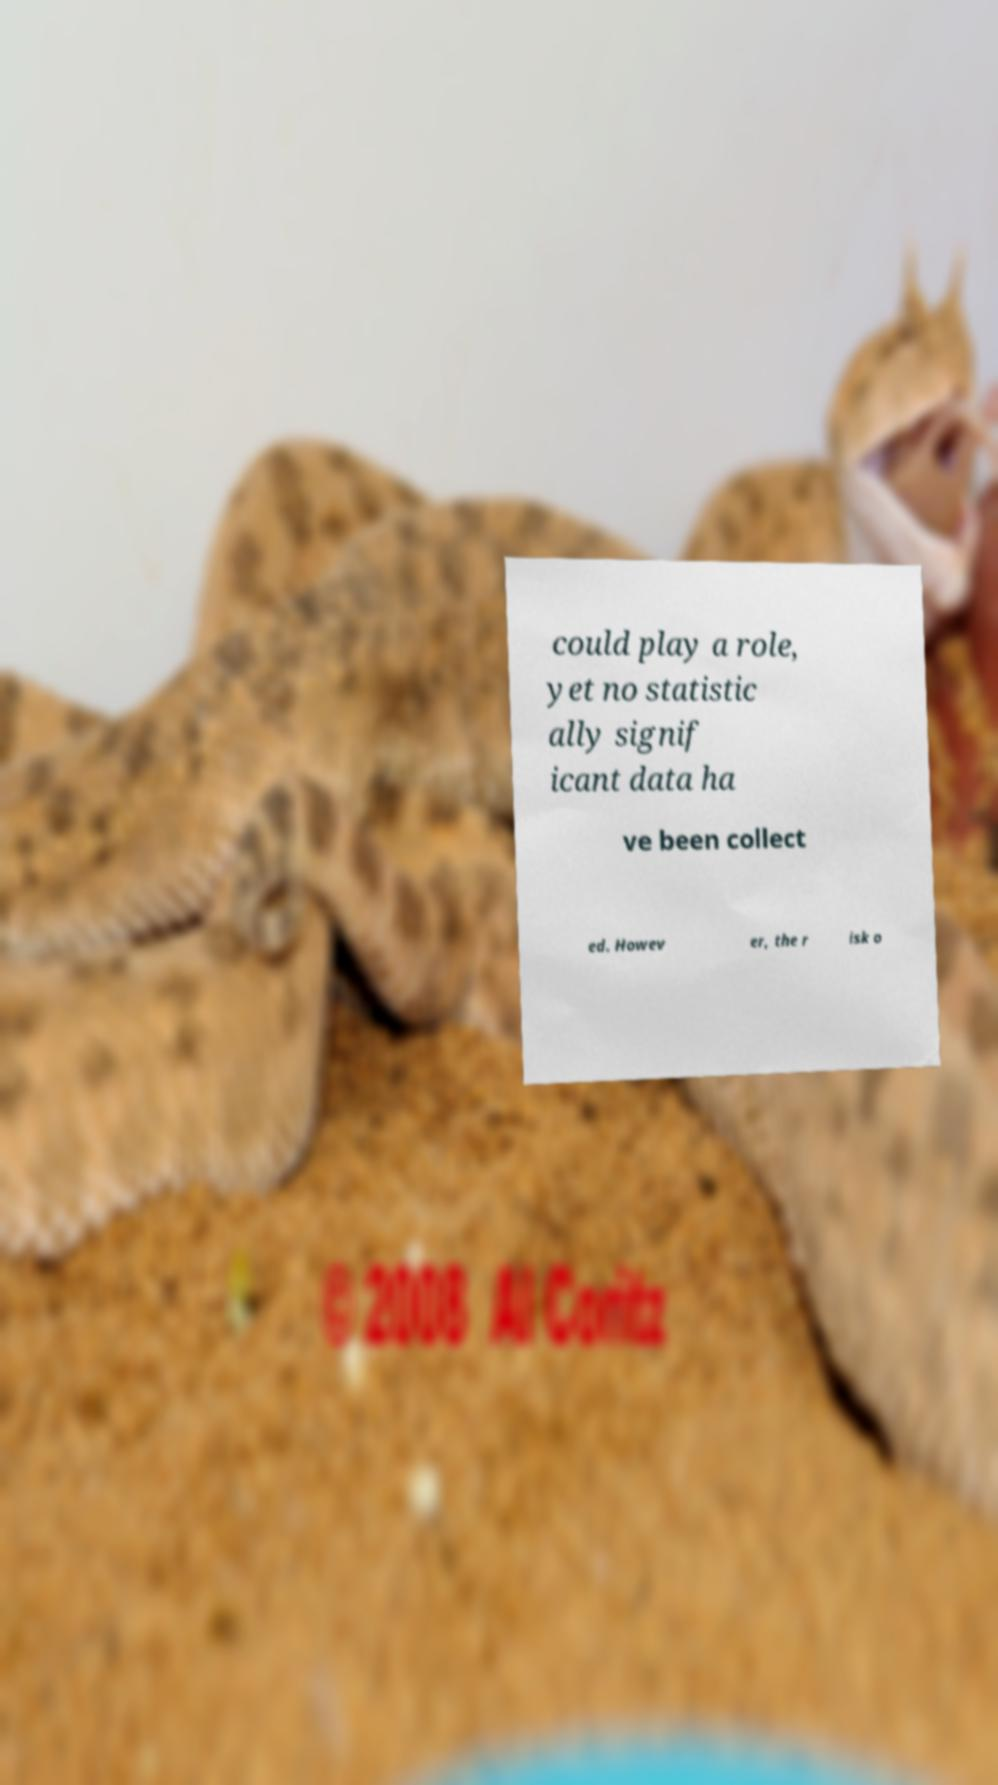Could you assist in decoding the text presented in this image and type it out clearly? could play a role, yet no statistic ally signif icant data ha ve been collect ed. Howev er, the r isk o 